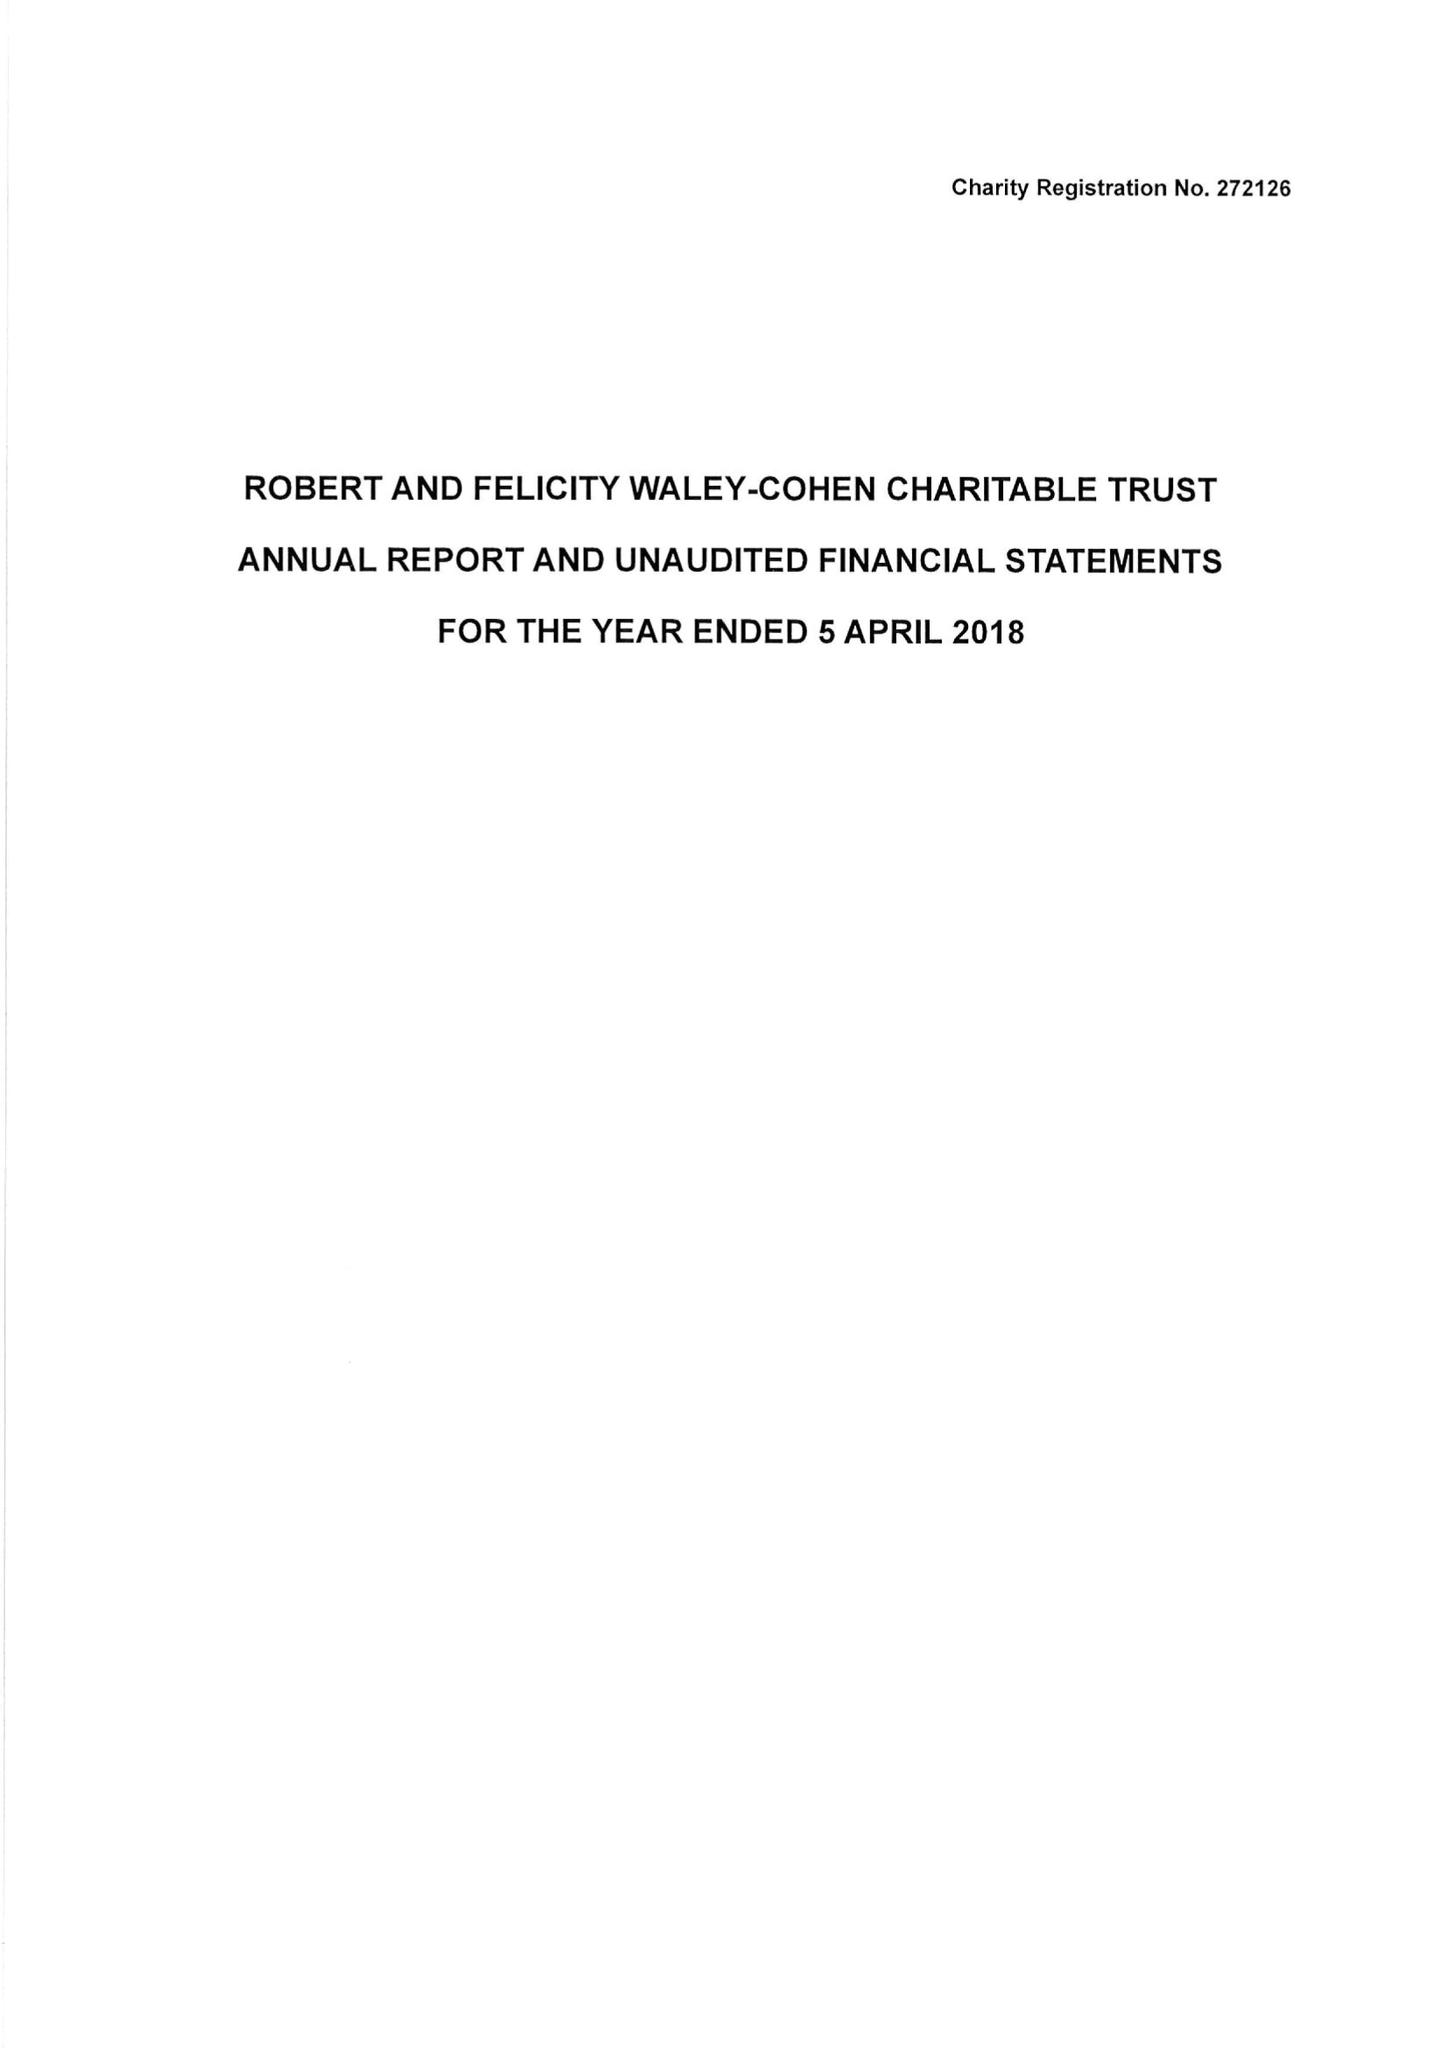What is the value for the address__postcode?
Answer the question using a single word or phrase. SW7 2TB 